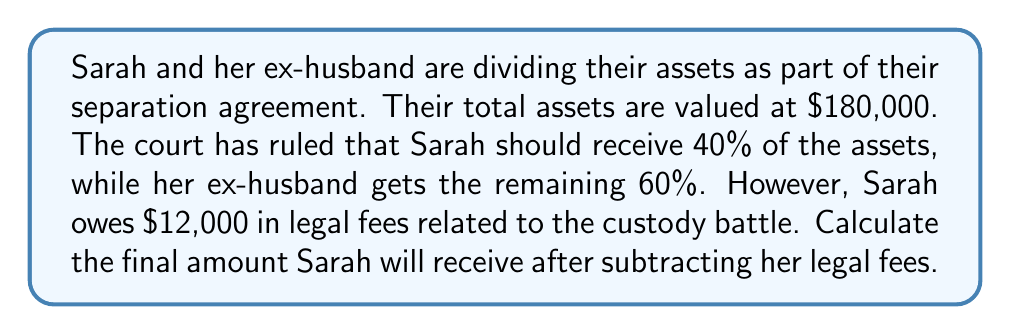Can you solve this math problem? Let's break this problem down into steps:

1. Calculate Sarah's share of the assets:
   $$\text{Sarah's share} = 40\% \text{ of } \$180,000$$
   $$= 0.40 \times \$180,000 = \$72,000$$

2. Subtract Sarah's legal fees from her share:
   $$\text{Final amount} = \text{Sarah's share} - \text{Legal fees}$$
   $$= \$72,000 - \$12,000 = \$60,000$$

Therefore, after subtracting her legal fees, Sarah will receive $60,000 from the division of assets.
Answer: $60,000 